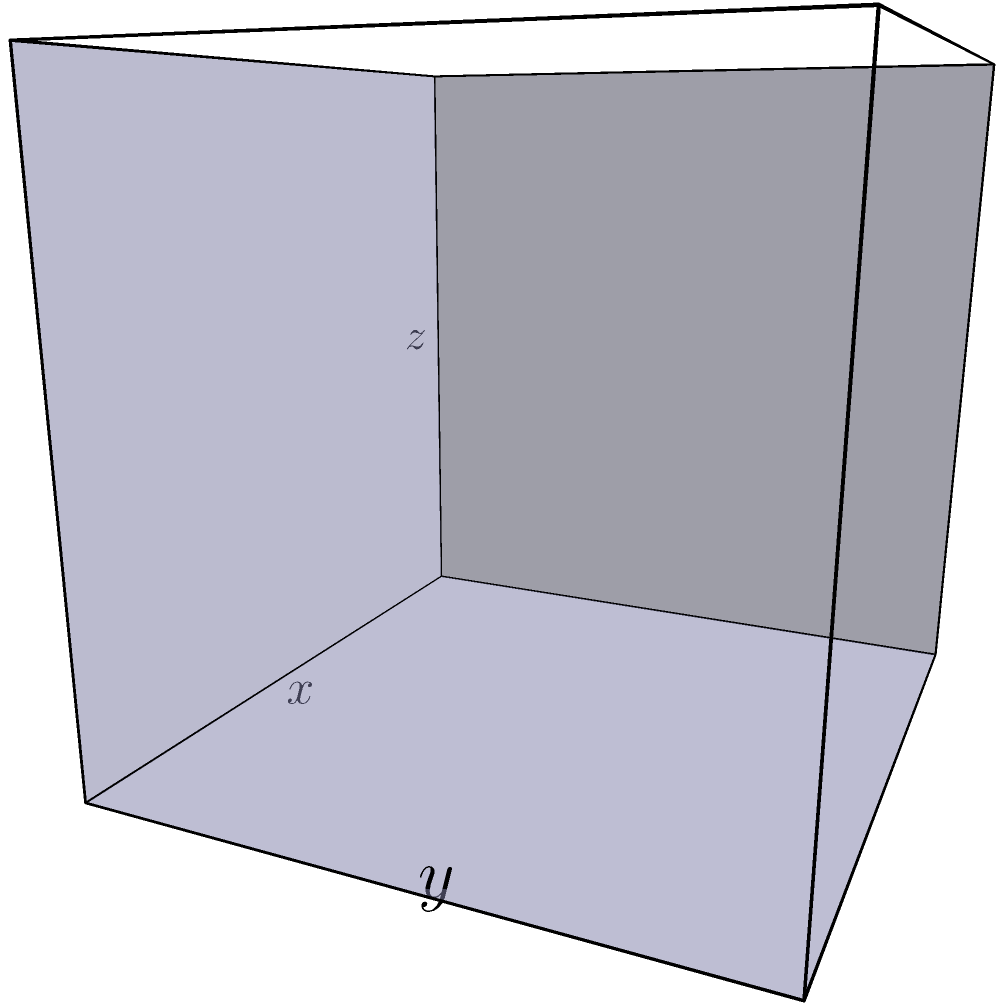A rectangular box with no top is to be constructed from a piece of cardboard with dimensions 12 inches by 8 inches. The box is formed by cutting equal squares from each corner and folding up the sides. Find the dimensions of the box that will maximize its volume. Let's approach this step-by-step:

1) Let $x$ be the side length of the square cut from each corner. Then:
   - The length of the box will be $12 - 2x$
   - The width of the box will be $8 - 2x$
   - The height of the box will be $x$

2) The volume $V$ of the box is given by:
   $V = x(12-2x)(8-2x)$

3) Expand this expression:
   $V = x(96 - 40x + 4x^2)$
   $V = 96x - 40x^2 + 4x^3$

4) To find the maximum volume, we need to find where $\frac{dV}{dx} = 0$:
   $\frac{dV}{dx} = 96 - 80x + 12x^2$

5) Set this equal to zero and solve:
   $96 - 80x + 12x^2 = 0$
   $12x^2 - 80x + 96 = 0$

6) This is a quadratic equation. We can solve it using the quadratic formula:
   $x = \frac{-b \pm \sqrt{b^2 - 4ac}}{2a}$

   Where $a=12$, $b=-80$, and $c=96$

7) Solving:
   $x = \frac{80 \pm \sqrt{6400 - 4608}}{24} = \frac{80 \pm \sqrt{1792}}{24} = \frac{80 \pm 42.33}{24}$

8) This gives us two solutions: $x \approx 5.10$ or $x \approx 1.57$

9) The second solution ($x \approx 1.57$) is the only one that makes sense in the context of our problem, as cutting 5.10 inch squares would be impossible with an 8 inch wide piece of cardboard.

10) Therefore, the optimal dimensions are:
    Length: $12 - 2(1.57) \approx 8.86$ inches
    Width: $8 - 2(1.57) \approx 4.86$ inches
    Height: $1.57$ inches
Answer: $8.86$ in × $4.86$ in × $1.57$ in 